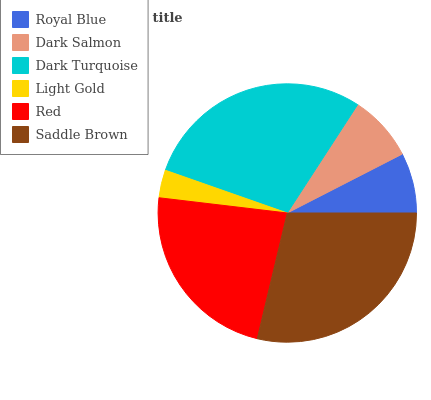Is Light Gold the minimum?
Answer yes or no. Yes. Is Dark Turquoise the maximum?
Answer yes or no. Yes. Is Dark Salmon the minimum?
Answer yes or no. No. Is Dark Salmon the maximum?
Answer yes or no. No. Is Dark Salmon greater than Royal Blue?
Answer yes or no. Yes. Is Royal Blue less than Dark Salmon?
Answer yes or no. Yes. Is Royal Blue greater than Dark Salmon?
Answer yes or no. No. Is Dark Salmon less than Royal Blue?
Answer yes or no. No. Is Red the high median?
Answer yes or no. Yes. Is Dark Salmon the low median?
Answer yes or no. Yes. Is Dark Turquoise the high median?
Answer yes or no. No. Is Light Gold the low median?
Answer yes or no. No. 